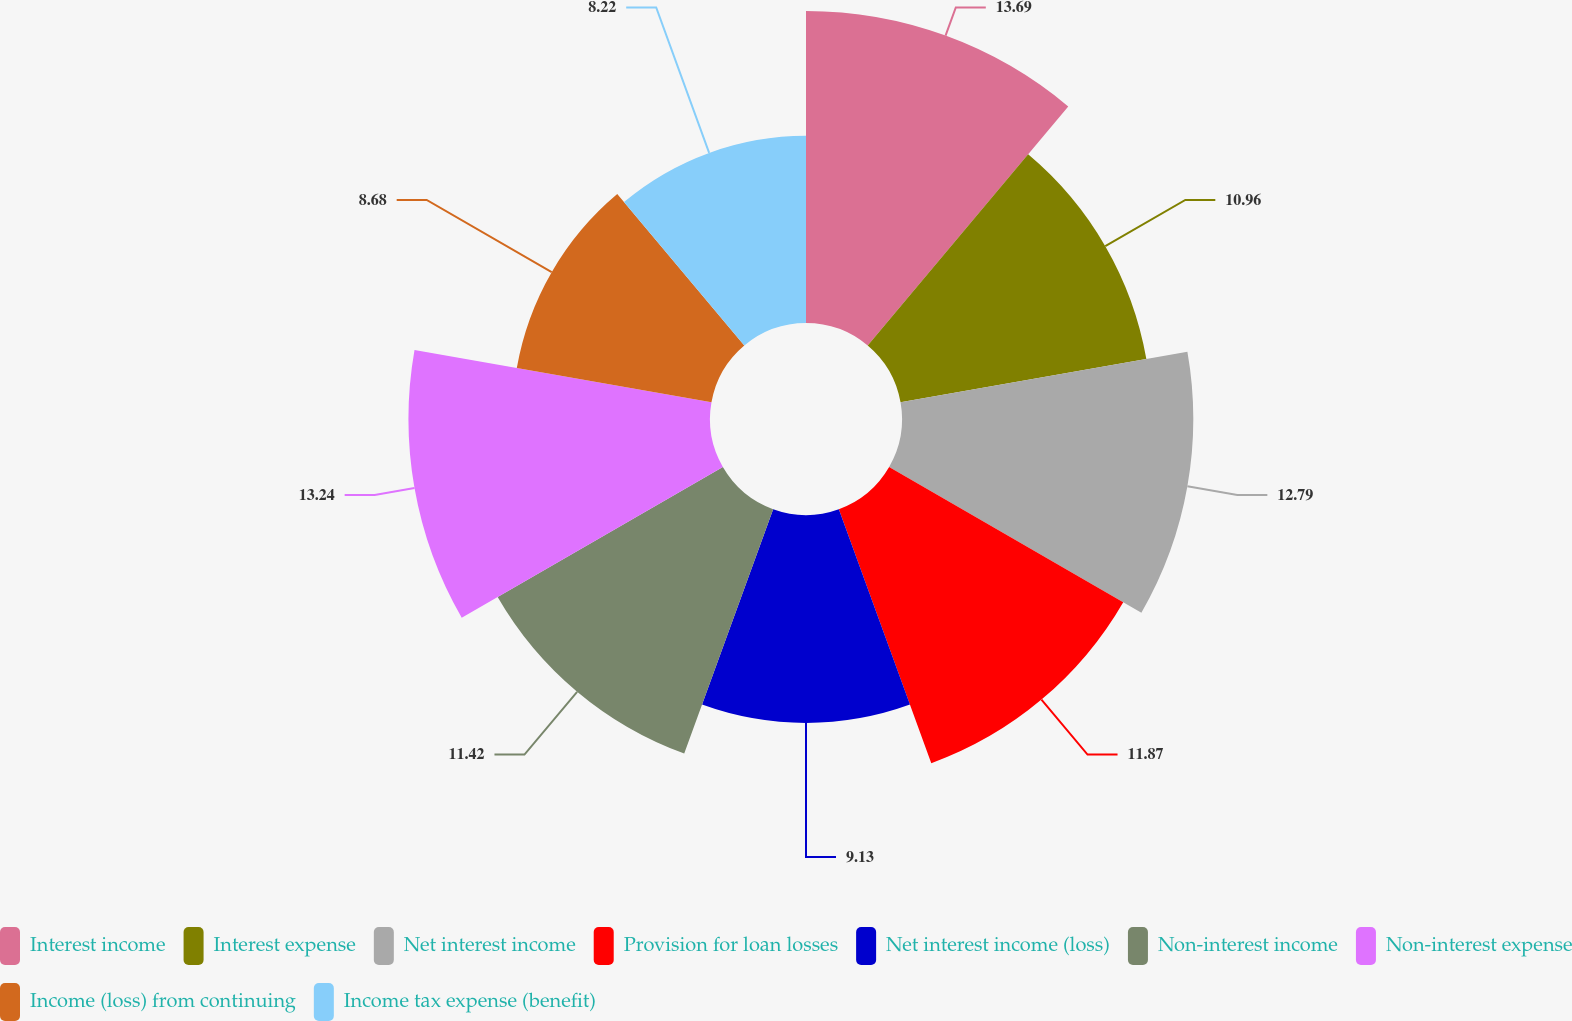Convert chart. <chart><loc_0><loc_0><loc_500><loc_500><pie_chart><fcel>Interest income<fcel>Interest expense<fcel>Net interest income<fcel>Provision for loan losses<fcel>Net interest income (loss)<fcel>Non-interest income<fcel>Non-interest expense<fcel>Income (loss) from continuing<fcel>Income tax expense (benefit)<nl><fcel>13.7%<fcel>10.96%<fcel>12.79%<fcel>11.87%<fcel>9.13%<fcel>11.42%<fcel>13.24%<fcel>8.68%<fcel>8.22%<nl></chart> 